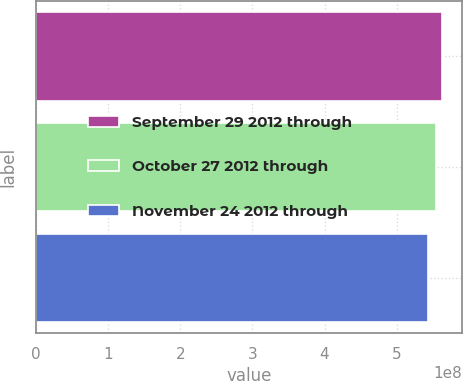<chart> <loc_0><loc_0><loc_500><loc_500><bar_chart><fcel>September 29 2012 through<fcel>October 27 2012 through<fcel>November 24 2012 through<nl><fcel>5.63008e+08<fcel>5.54874e+08<fcel>5.42943e+08<nl></chart> 